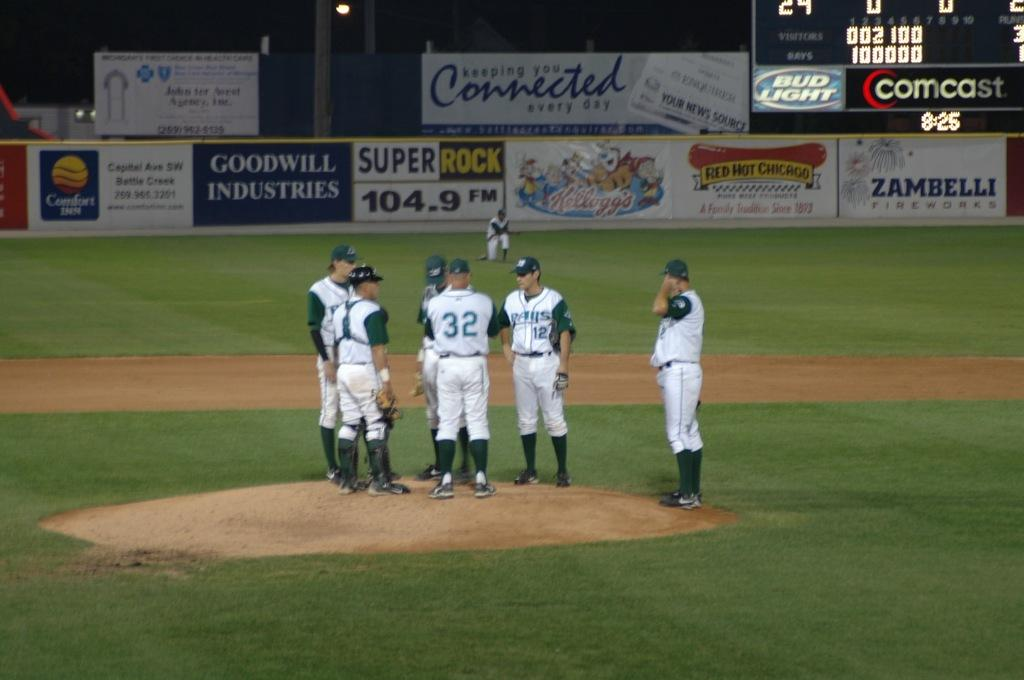<image>
Offer a succinct explanation of the picture presented. Baseball players standing on the field in front of a banner that has Connected in blue letters. 